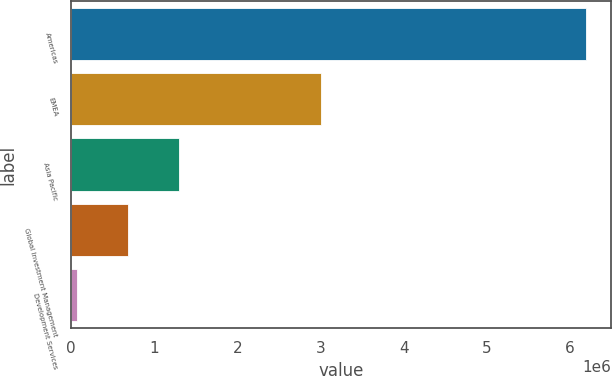<chart> <loc_0><loc_0><loc_500><loc_500><bar_chart><fcel>Americas<fcel>EMEA<fcel>Asia Pacific<fcel>Global Investment Management<fcel>Development Services<nl><fcel>6.18991e+06<fcel>3.00448e+06<fcel>1.2905e+06<fcel>678070<fcel>65643<nl></chart> 